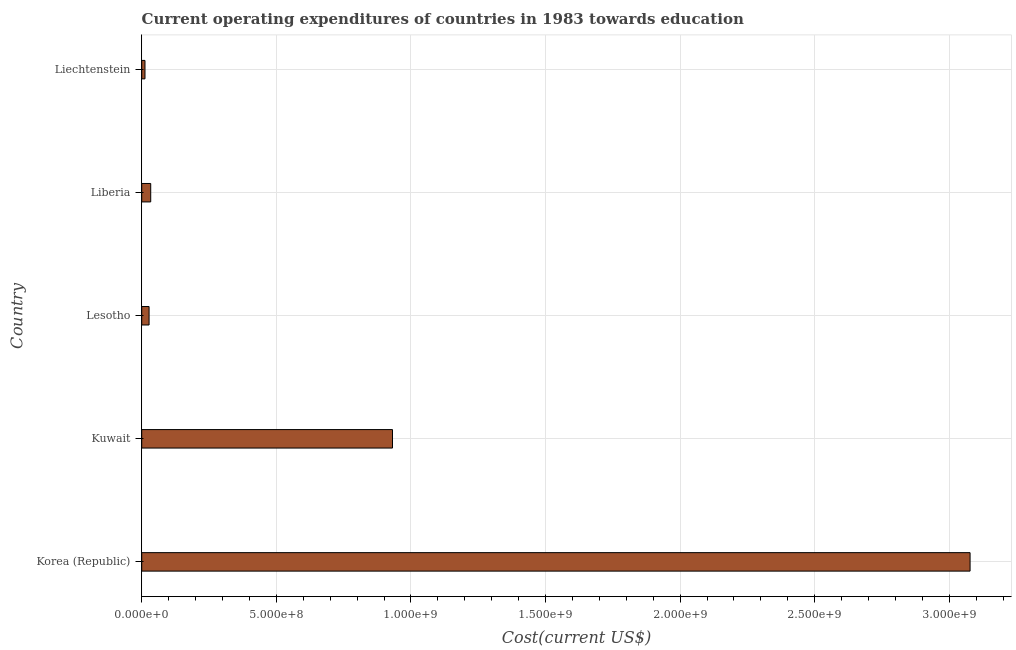Does the graph contain any zero values?
Ensure brevity in your answer.  No. Does the graph contain grids?
Your answer should be compact. Yes. What is the title of the graph?
Your response must be concise. Current operating expenditures of countries in 1983 towards education. What is the label or title of the X-axis?
Provide a short and direct response. Cost(current US$). What is the label or title of the Y-axis?
Provide a succinct answer. Country. What is the education expenditure in Kuwait?
Offer a very short reply. 9.32e+08. Across all countries, what is the maximum education expenditure?
Provide a short and direct response. 3.08e+09. Across all countries, what is the minimum education expenditure?
Ensure brevity in your answer.  1.21e+07. In which country was the education expenditure minimum?
Offer a very short reply. Liechtenstein. What is the sum of the education expenditure?
Offer a very short reply. 4.08e+09. What is the difference between the education expenditure in Korea (Republic) and Kuwait?
Your response must be concise. 2.15e+09. What is the average education expenditure per country?
Provide a short and direct response. 8.16e+08. What is the median education expenditure?
Provide a succinct answer. 3.34e+07. What is the ratio of the education expenditure in Korea (Republic) to that in Liechtenstein?
Ensure brevity in your answer.  254.27. Is the education expenditure in Korea (Republic) less than that in Lesotho?
Provide a succinct answer. No. Is the difference between the education expenditure in Korea (Republic) and Kuwait greater than the difference between any two countries?
Your response must be concise. No. What is the difference between the highest and the second highest education expenditure?
Offer a very short reply. 2.15e+09. What is the difference between the highest and the lowest education expenditure?
Keep it short and to the point. 3.06e+09. In how many countries, is the education expenditure greater than the average education expenditure taken over all countries?
Keep it short and to the point. 2. How many bars are there?
Your response must be concise. 5. What is the Cost(current US$) of Korea (Republic)?
Ensure brevity in your answer.  3.08e+09. What is the Cost(current US$) in Kuwait?
Provide a short and direct response. 9.32e+08. What is the Cost(current US$) of Lesotho?
Make the answer very short. 2.73e+07. What is the Cost(current US$) in Liberia?
Ensure brevity in your answer.  3.34e+07. What is the Cost(current US$) of Liechtenstein?
Ensure brevity in your answer.  1.21e+07. What is the difference between the Cost(current US$) in Korea (Republic) and Kuwait?
Provide a short and direct response. 2.15e+09. What is the difference between the Cost(current US$) in Korea (Republic) and Lesotho?
Make the answer very short. 3.05e+09. What is the difference between the Cost(current US$) in Korea (Republic) and Liberia?
Keep it short and to the point. 3.04e+09. What is the difference between the Cost(current US$) in Korea (Republic) and Liechtenstein?
Your answer should be compact. 3.06e+09. What is the difference between the Cost(current US$) in Kuwait and Lesotho?
Offer a terse response. 9.04e+08. What is the difference between the Cost(current US$) in Kuwait and Liberia?
Offer a terse response. 8.98e+08. What is the difference between the Cost(current US$) in Kuwait and Liechtenstein?
Your answer should be compact. 9.19e+08. What is the difference between the Cost(current US$) in Lesotho and Liberia?
Your answer should be compact. -6.13e+06. What is the difference between the Cost(current US$) in Lesotho and Liechtenstein?
Your answer should be very brief. 1.52e+07. What is the difference between the Cost(current US$) in Liberia and Liechtenstein?
Ensure brevity in your answer.  2.13e+07. What is the ratio of the Cost(current US$) in Korea (Republic) to that in Kuwait?
Keep it short and to the point. 3.3. What is the ratio of the Cost(current US$) in Korea (Republic) to that in Lesotho?
Your response must be concise. 112.68. What is the ratio of the Cost(current US$) in Korea (Republic) to that in Liberia?
Offer a very short reply. 92.02. What is the ratio of the Cost(current US$) in Korea (Republic) to that in Liechtenstein?
Offer a terse response. 254.27. What is the ratio of the Cost(current US$) in Kuwait to that in Lesotho?
Offer a terse response. 34.11. What is the ratio of the Cost(current US$) in Kuwait to that in Liberia?
Ensure brevity in your answer.  27.86. What is the ratio of the Cost(current US$) in Kuwait to that in Liechtenstein?
Provide a short and direct response. 76.98. What is the ratio of the Cost(current US$) in Lesotho to that in Liberia?
Provide a succinct answer. 0.82. What is the ratio of the Cost(current US$) in Lesotho to that in Liechtenstein?
Make the answer very short. 2.26. What is the ratio of the Cost(current US$) in Liberia to that in Liechtenstein?
Give a very brief answer. 2.76. 